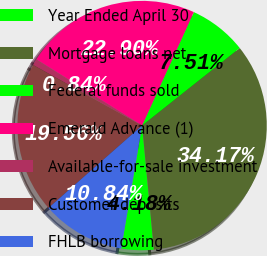Convert chart. <chart><loc_0><loc_0><loc_500><loc_500><pie_chart><fcel>Year Ended April 30<fcel>Mortgage loans net<fcel>Federal funds sold<fcel>Emerald Advance (1)<fcel>Available-for-sale investment<fcel>Customer deposits<fcel>FHLB borrowing<nl><fcel>4.18%<fcel>34.17%<fcel>7.51%<fcel>22.9%<fcel>0.84%<fcel>19.56%<fcel>10.84%<nl></chart> 